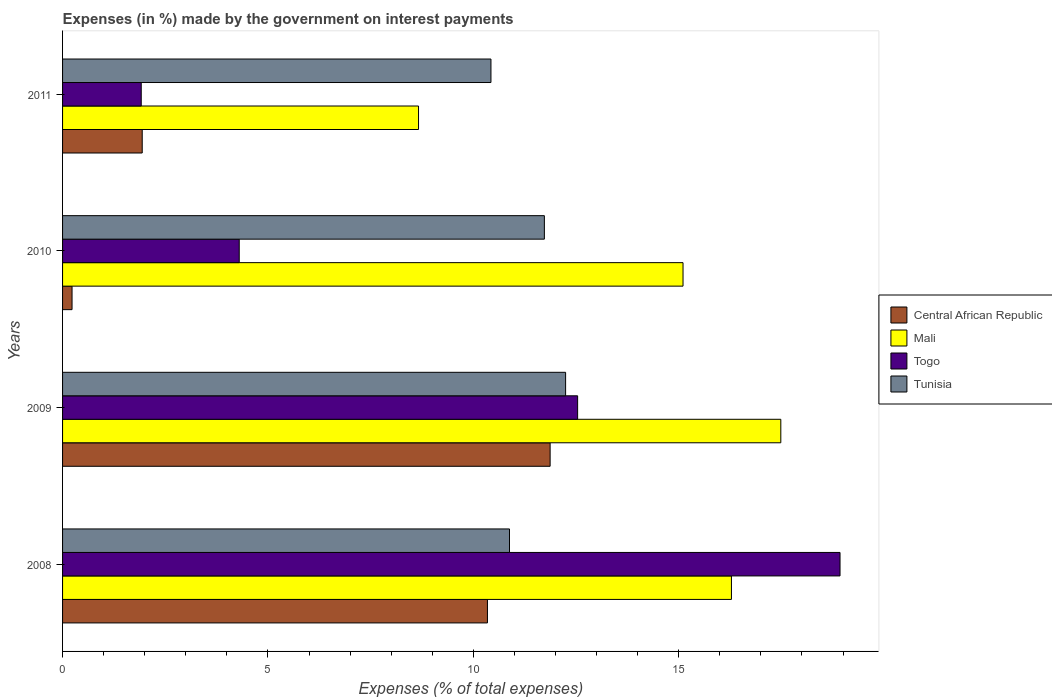Are the number of bars per tick equal to the number of legend labels?
Provide a short and direct response. Yes. How many bars are there on the 4th tick from the top?
Offer a terse response. 4. What is the label of the 3rd group of bars from the top?
Your answer should be very brief. 2009. In how many cases, is the number of bars for a given year not equal to the number of legend labels?
Give a very brief answer. 0. What is the percentage of expenses made by the government on interest payments in Tunisia in 2009?
Offer a terse response. 12.25. Across all years, what is the maximum percentage of expenses made by the government on interest payments in Mali?
Your response must be concise. 17.49. Across all years, what is the minimum percentage of expenses made by the government on interest payments in Mali?
Provide a succinct answer. 8.67. In which year was the percentage of expenses made by the government on interest payments in Mali maximum?
Your answer should be compact. 2009. In which year was the percentage of expenses made by the government on interest payments in Togo minimum?
Your answer should be compact. 2011. What is the total percentage of expenses made by the government on interest payments in Central African Republic in the graph?
Your answer should be very brief. 24.38. What is the difference between the percentage of expenses made by the government on interest payments in Tunisia in 2010 and that in 2011?
Offer a very short reply. 1.3. What is the difference between the percentage of expenses made by the government on interest payments in Tunisia in 2010 and the percentage of expenses made by the government on interest payments in Central African Republic in 2008?
Offer a terse response. 1.39. What is the average percentage of expenses made by the government on interest payments in Mali per year?
Offer a terse response. 14.39. In the year 2009, what is the difference between the percentage of expenses made by the government on interest payments in Tunisia and percentage of expenses made by the government on interest payments in Mali?
Make the answer very short. -5.24. What is the ratio of the percentage of expenses made by the government on interest payments in Central African Republic in 2008 to that in 2010?
Give a very brief answer. 44.79. Is the percentage of expenses made by the government on interest payments in Tunisia in 2010 less than that in 2011?
Offer a terse response. No. What is the difference between the highest and the second highest percentage of expenses made by the government on interest payments in Togo?
Your answer should be very brief. 6.39. What is the difference between the highest and the lowest percentage of expenses made by the government on interest payments in Tunisia?
Provide a succinct answer. 1.82. In how many years, is the percentage of expenses made by the government on interest payments in Tunisia greater than the average percentage of expenses made by the government on interest payments in Tunisia taken over all years?
Keep it short and to the point. 2. Is the sum of the percentage of expenses made by the government on interest payments in Tunisia in 2008 and 2010 greater than the maximum percentage of expenses made by the government on interest payments in Central African Republic across all years?
Ensure brevity in your answer.  Yes. What does the 2nd bar from the top in 2008 represents?
Your answer should be very brief. Togo. What does the 3rd bar from the bottom in 2011 represents?
Ensure brevity in your answer.  Togo. Is it the case that in every year, the sum of the percentage of expenses made by the government on interest payments in Togo and percentage of expenses made by the government on interest payments in Tunisia is greater than the percentage of expenses made by the government on interest payments in Central African Republic?
Your answer should be very brief. Yes. How many bars are there?
Make the answer very short. 16. How many years are there in the graph?
Your response must be concise. 4. What is the difference between two consecutive major ticks on the X-axis?
Offer a very short reply. 5. Are the values on the major ticks of X-axis written in scientific E-notation?
Your answer should be compact. No. Does the graph contain any zero values?
Give a very brief answer. No. Where does the legend appear in the graph?
Provide a succinct answer. Center right. How are the legend labels stacked?
Provide a short and direct response. Vertical. What is the title of the graph?
Offer a terse response. Expenses (in %) made by the government on interest payments. Does "Latin America(all income levels)" appear as one of the legend labels in the graph?
Your answer should be compact. No. What is the label or title of the X-axis?
Your answer should be compact. Expenses (% of total expenses). What is the label or title of the Y-axis?
Offer a very short reply. Years. What is the Expenses (% of total expenses) of Central African Republic in 2008?
Make the answer very short. 10.34. What is the Expenses (% of total expenses) of Mali in 2008?
Ensure brevity in your answer.  16.28. What is the Expenses (% of total expenses) of Togo in 2008?
Your response must be concise. 18.93. What is the Expenses (% of total expenses) of Tunisia in 2008?
Provide a succinct answer. 10.88. What is the Expenses (% of total expenses) of Central African Republic in 2009?
Ensure brevity in your answer.  11.87. What is the Expenses (% of total expenses) of Mali in 2009?
Offer a very short reply. 17.49. What is the Expenses (% of total expenses) in Togo in 2009?
Provide a short and direct response. 12.54. What is the Expenses (% of total expenses) of Tunisia in 2009?
Provide a short and direct response. 12.25. What is the Expenses (% of total expenses) of Central African Republic in 2010?
Make the answer very short. 0.23. What is the Expenses (% of total expenses) in Mali in 2010?
Provide a succinct answer. 15.11. What is the Expenses (% of total expenses) of Togo in 2010?
Your answer should be very brief. 4.3. What is the Expenses (% of total expenses) in Tunisia in 2010?
Provide a succinct answer. 11.73. What is the Expenses (% of total expenses) of Central African Republic in 2011?
Provide a succinct answer. 1.94. What is the Expenses (% of total expenses) in Mali in 2011?
Your answer should be compact. 8.67. What is the Expenses (% of total expenses) of Togo in 2011?
Provide a short and direct response. 1.92. What is the Expenses (% of total expenses) in Tunisia in 2011?
Provide a short and direct response. 10.43. Across all years, what is the maximum Expenses (% of total expenses) of Central African Republic?
Your answer should be compact. 11.87. Across all years, what is the maximum Expenses (% of total expenses) of Mali?
Ensure brevity in your answer.  17.49. Across all years, what is the maximum Expenses (% of total expenses) in Togo?
Your response must be concise. 18.93. Across all years, what is the maximum Expenses (% of total expenses) of Tunisia?
Offer a terse response. 12.25. Across all years, what is the minimum Expenses (% of total expenses) in Central African Republic?
Offer a terse response. 0.23. Across all years, what is the minimum Expenses (% of total expenses) of Mali?
Give a very brief answer. 8.67. Across all years, what is the minimum Expenses (% of total expenses) of Togo?
Offer a very short reply. 1.92. Across all years, what is the minimum Expenses (% of total expenses) in Tunisia?
Offer a very short reply. 10.43. What is the total Expenses (% of total expenses) of Central African Republic in the graph?
Make the answer very short. 24.38. What is the total Expenses (% of total expenses) of Mali in the graph?
Give a very brief answer. 57.54. What is the total Expenses (% of total expenses) of Togo in the graph?
Keep it short and to the point. 37.68. What is the total Expenses (% of total expenses) in Tunisia in the graph?
Ensure brevity in your answer.  45.29. What is the difference between the Expenses (% of total expenses) of Central African Republic in 2008 and that in 2009?
Your answer should be compact. -1.53. What is the difference between the Expenses (% of total expenses) of Mali in 2008 and that in 2009?
Your answer should be compact. -1.2. What is the difference between the Expenses (% of total expenses) in Togo in 2008 and that in 2009?
Offer a very short reply. 6.39. What is the difference between the Expenses (% of total expenses) of Tunisia in 2008 and that in 2009?
Ensure brevity in your answer.  -1.37. What is the difference between the Expenses (% of total expenses) of Central African Republic in 2008 and that in 2010?
Keep it short and to the point. 10.11. What is the difference between the Expenses (% of total expenses) in Mali in 2008 and that in 2010?
Your answer should be compact. 1.18. What is the difference between the Expenses (% of total expenses) in Togo in 2008 and that in 2010?
Offer a very short reply. 14.63. What is the difference between the Expenses (% of total expenses) in Tunisia in 2008 and that in 2010?
Offer a terse response. -0.85. What is the difference between the Expenses (% of total expenses) in Central African Republic in 2008 and that in 2011?
Offer a very short reply. 8.4. What is the difference between the Expenses (% of total expenses) of Mali in 2008 and that in 2011?
Your answer should be very brief. 7.62. What is the difference between the Expenses (% of total expenses) in Togo in 2008 and that in 2011?
Offer a terse response. 17.01. What is the difference between the Expenses (% of total expenses) in Tunisia in 2008 and that in 2011?
Your answer should be very brief. 0.45. What is the difference between the Expenses (% of total expenses) of Central African Republic in 2009 and that in 2010?
Your answer should be compact. 11.64. What is the difference between the Expenses (% of total expenses) of Mali in 2009 and that in 2010?
Provide a short and direct response. 2.38. What is the difference between the Expenses (% of total expenses) of Togo in 2009 and that in 2010?
Offer a terse response. 8.24. What is the difference between the Expenses (% of total expenses) of Tunisia in 2009 and that in 2010?
Ensure brevity in your answer.  0.52. What is the difference between the Expenses (% of total expenses) of Central African Republic in 2009 and that in 2011?
Provide a short and direct response. 9.93. What is the difference between the Expenses (% of total expenses) of Mali in 2009 and that in 2011?
Provide a short and direct response. 8.82. What is the difference between the Expenses (% of total expenses) of Togo in 2009 and that in 2011?
Make the answer very short. 10.62. What is the difference between the Expenses (% of total expenses) in Tunisia in 2009 and that in 2011?
Provide a succinct answer. 1.82. What is the difference between the Expenses (% of total expenses) of Central African Republic in 2010 and that in 2011?
Provide a succinct answer. -1.71. What is the difference between the Expenses (% of total expenses) of Mali in 2010 and that in 2011?
Your answer should be very brief. 6.44. What is the difference between the Expenses (% of total expenses) of Togo in 2010 and that in 2011?
Offer a terse response. 2.39. What is the difference between the Expenses (% of total expenses) in Tunisia in 2010 and that in 2011?
Offer a very short reply. 1.3. What is the difference between the Expenses (% of total expenses) in Central African Republic in 2008 and the Expenses (% of total expenses) in Mali in 2009?
Your answer should be very brief. -7.14. What is the difference between the Expenses (% of total expenses) in Central African Republic in 2008 and the Expenses (% of total expenses) in Togo in 2009?
Your answer should be compact. -2.2. What is the difference between the Expenses (% of total expenses) of Central African Republic in 2008 and the Expenses (% of total expenses) of Tunisia in 2009?
Ensure brevity in your answer.  -1.9. What is the difference between the Expenses (% of total expenses) of Mali in 2008 and the Expenses (% of total expenses) of Togo in 2009?
Make the answer very short. 3.74. What is the difference between the Expenses (% of total expenses) in Mali in 2008 and the Expenses (% of total expenses) in Tunisia in 2009?
Your answer should be compact. 4.04. What is the difference between the Expenses (% of total expenses) of Togo in 2008 and the Expenses (% of total expenses) of Tunisia in 2009?
Ensure brevity in your answer.  6.68. What is the difference between the Expenses (% of total expenses) of Central African Republic in 2008 and the Expenses (% of total expenses) of Mali in 2010?
Keep it short and to the point. -4.76. What is the difference between the Expenses (% of total expenses) in Central African Republic in 2008 and the Expenses (% of total expenses) in Togo in 2010?
Provide a succinct answer. 6.04. What is the difference between the Expenses (% of total expenses) in Central African Republic in 2008 and the Expenses (% of total expenses) in Tunisia in 2010?
Your answer should be compact. -1.39. What is the difference between the Expenses (% of total expenses) of Mali in 2008 and the Expenses (% of total expenses) of Togo in 2010?
Offer a very short reply. 11.98. What is the difference between the Expenses (% of total expenses) in Mali in 2008 and the Expenses (% of total expenses) in Tunisia in 2010?
Your answer should be compact. 4.55. What is the difference between the Expenses (% of total expenses) of Togo in 2008 and the Expenses (% of total expenses) of Tunisia in 2010?
Offer a terse response. 7.2. What is the difference between the Expenses (% of total expenses) of Central African Republic in 2008 and the Expenses (% of total expenses) of Mali in 2011?
Your answer should be compact. 1.68. What is the difference between the Expenses (% of total expenses) in Central African Republic in 2008 and the Expenses (% of total expenses) in Togo in 2011?
Your response must be concise. 8.43. What is the difference between the Expenses (% of total expenses) of Central African Republic in 2008 and the Expenses (% of total expenses) of Tunisia in 2011?
Your answer should be compact. -0.09. What is the difference between the Expenses (% of total expenses) in Mali in 2008 and the Expenses (% of total expenses) in Togo in 2011?
Your answer should be compact. 14.37. What is the difference between the Expenses (% of total expenses) in Mali in 2008 and the Expenses (% of total expenses) in Tunisia in 2011?
Offer a very short reply. 5.85. What is the difference between the Expenses (% of total expenses) in Togo in 2008 and the Expenses (% of total expenses) in Tunisia in 2011?
Keep it short and to the point. 8.5. What is the difference between the Expenses (% of total expenses) of Central African Republic in 2009 and the Expenses (% of total expenses) of Mali in 2010?
Provide a succinct answer. -3.24. What is the difference between the Expenses (% of total expenses) of Central African Republic in 2009 and the Expenses (% of total expenses) of Togo in 2010?
Ensure brevity in your answer.  7.57. What is the difference between the Expenses (% of total expenses) of Central African Republic in 2009 and the Expenses (% of total expenses) of Tunisia in 2010?
Provide a succinct answer. 0.14. What is the difference between the Expenses (% of total expenses) in Mali in 2009 and the Expenses (% of total expenses) in Togo in 2010?
Provide a short and direct response. 13.19. What is the difference between the Expenses (% of total expenses) in Mali in 2009 and the Expenses (% of total expenses) in Tunisia in 2010?
Provide a short and direct response. 5.76. What is the difference between the Expenses (% of total expenses) of Togo in 2009 and the Expenses (% of total expenses) of Tunisia in 2010?
Your response must be concise. 0.81. What is the difference between the Expenses (% of total expenses) of Central African Republic in 2009 and the Expenses (% of total expenses) of Mali in 2011?
Make the answer very short. 3.2. What is the difference between the Expenses (% of total expenses) in Central African Republic in 2009 and the Expenses (% of total expenses) in Togo in 2011?
Your response must be concise. 9.95. What is the difference between the Expenses (% of total expenses) in Central African Republic in 2009 and the Expenses (% of total expenses) in Tunisia in 2011?
Provide a succinct answer. 1.44. What is the difference between the Expenses (% of total expenses) of Mali in 2009 and the Expenses (% of total expenses) of Togo in 2011?
Offer a terse response. 15.57. What is the difference between the Expenses (% of total expenses) in Mali in 2009 and the Expenses (% of total expenses) in Tunisia in 2011?
Ensure brevity in your answer.  7.06. What is the difference between the Expenses (% of total expenses) of Togo in 2009 and the Expenses (% of total expenses) of Tunisia in 2011?
Your response must be concise. 2.11. What is the difference between the Expenses (% of total expenses) in Central African Republic in 2010 and the Expenses (% of total expenses) in Mali in 2011?
Your response must be concise. -8.44. What is the difference between the Expenses (% of total expenses) of Central African Republic in 2010 and the Expenses (% of total expenses) of Togo in 2011?
Provide a short and direct response. -1.68. What is the difference between the Expenses (% of total expenses) in Central African Republic in 2010 and the Expenses (% of total expenses) in Tunisia in 2011?
Offer a terse response. -10.2. What is the difference between the Expenses (% of total expenses) of Mali in 2010 and the Expenses (% of total expenses) of Togo in 2011?
Offer a very short reply. 13.19. What is the difference between the Expenses (% of total expenses) in Mali in 2010 and the Expenses (% of total expenses) in Tunisia in 2011?
Make the answer very short. 4.68. What is the difference between the Expenses (% of total expenses) in Togo in 2010 and the Expenses (% of total expenses) in Tunisia in 2011?
Your answer should be very brief. -6.13. What is the average Expenses (% of total expenses) in Central African Republic per year?
Offer a very short reply. 6.1. What is the average Expenses (% of total expenses) in Mali per year?
Provide a succinct answer. 14.39. What is the average Expenses (% of total expenses) of Togo per year?
Offer a terse response. 9.42. What is the average Expenses (% of total expenses) in Tunisia per year?
Offer a terse response. 11.32. In the year 2008, what is the difference between the Expenses (% of total expenses) in Central African Republic and Expenses (% of total expenses) in Mali?
Make the answer very short. -5.94. In the year 2008, what is the difference between the Expenses (% of total expenses) of Central African Republic and Expenses (% of total expenses) of Togo?
Provide a succinct answer. -8.58. In the year 2008, what is the difference between the Expenses (% of total expenses) of Central African Republic and Expenses (% of total expenses) of Tunisia?
Offer a very short reply. -0.54. In the year 2008, what is the difference between the Expenses (% of total expenses) of Mali and Expenses (% of total expenses) of Togo?
Your answer should be very brief. -2.64. In the year 2008, what is the difference between the Expenses (% of total expenses) of Mali and Expenses (% of total expenses) of Tunisia?
Your response must be concise. 5.4. In the year 2008, what is the difference between the Expenses (% of total expenses) in Togo and Expenses (% of total expenses) in Tunisia?
Make the answer very short. 8.05. In the year 2009, what is the difference between the Expenses (% of total expenses) of Central African Republic and Expenses (% of total expenses) of Mali?
Offer a very short reply. -5.62. In the year 2009, what is the difference between the Expenses (% of total expenses) of Central African Republic and Expenses (% of total expenses) of Togo?
Offer a terse response. -0.67. In the year 2009, what is the difference between the Expenses (% of total expenses) in Central African Republic and Expenses (% of total expenses) in Tunisia?
Your answer should be compact. -0.38. In the year 2009, what is the difference between the Expenses (% of total expenses) in Mali and Expenses (% of total expenses) in Togo?
Provide a short and direct response. 4.95. In the year 2009, what is the difference between the Expenses (% of total expenses) of Mali and Expenses (% of total expenses) of Tunisia?
Offer a very short reply. 5.24. In the year 2009, what is the difference between the Expenses (% of total expenses) of Togo and Expenses (% of total expenses) of Tunisia?
Offer a very short reply. 0.29. In the year 2010, what is the difference between the Expenses (% of total expenses) in Central African Republic and Expenses (% of total expenses) in Mali?
Provide a short and direct response. -14.87. In the year 2010, what is the difference between the Expenses (% of total expenses) of Central African Republic and Expenses (% of total expenses) of Togo?
Your answer should be compact. -4.07. In the year 2010, what is the difference between the Expenses (% of total expenses) of Central African Republic and Expenses (% of total expenses) of Tunisia?
Offer a terse response. -11.5. In the year 2010, what is the difference between the Expenses (% of total expenses) of Mali and Expenses (% of total expenses) of Togo?
Ensure brevity in your answer.  10.8. In the year 2010, what is the difference between the Expenses (% of total expenses) of Mali and Expenses (% of total expenses) of Tunisia?
Provide a succinct answer. 3.38. In the year 2010, what is the difference between the Expenses (% of total expenses) of Togo and Expenses (% of total expenses) of Tunisia?
Your response must be concise. -7.43. In the year 2011, what is the difference between the Expenses (% of total expenses) of Central African Republic and Expenses (% of total expenses) of Mali?
Offer a very short reply. -6.73. In the year 2011, what is the difference between the Expenses (% of total expenses) of Central African Republic and Expenses (% of total expenses) of Togo?
Provide a succinct answer. 0.02. In the year 2011, what is the difference between the Expenses (% of total expenses) in Central African Republic and Expenses (% of total expenses) in Tunisia?
Your answer should be compact. -8.49. In the year 2011, what is the difference between the Expenses (% of total expenses) in Mali and Expenses (% of total expenses) in Togo?
Provide a short and direct response. 6.75. In the year 2011, what is the difference between the Expenses (% of total expenses) of Mali and Expenses (% of total expenses) of Tunisia?
Make the answer very short. -1.76. In the year 2011, what is the difference between the Expenses (% of total expenses) in Togo and Expenses (% of total expenses) in Tunisia?
Keep it short and to the point. -8.51. What is the ratio of the Expenses (% of total expenses) of Central African Republic in 2008 to that in 2009?
Your response must be concise. 0.87. What is the ratio of the Expenses (% of total expenses) in Mali in 2008 to that in 2009?
Offer a terse response. 0.93. What is the ratio of the Expenses (% of total expenses) of Togo in 2008 to that in 2009?
Offer a very short reply. 1.51. What is the ratio of the Expenses (% of total expenses) of Tunisia in 2008 to that in 2009?
Make the answer very short. 0.89. What is the ratio of the Expenses (% of total expenses) in Central African Republic in 2008 to that in 2010?
Provide a succinct answer. 44.79. What is the ratio of the Expenses (% of total expenses) of Mali in 2008 to that in 2010?
Your response must be concise. 1.08. What is the ratio of the Expenses (% of total expenses) of Togo in 2008 to that in 2010?
Provide a succinct answer. 4.4. What is the ratio of the Expenses (% of total expenses) in Tunisia in 2008 to that in 2010?
Make the answer very short. 0.93. What is the ratio of the Expenses (% of total expenses) in Central African Republic in 2008 to that in 2011?
Provide a short and direct response. 5.33. What is the ratio of the Expenses (% of total expenses) of Mali in 2008 to that in 2011?
Offer a terse response. 1.88. What is the ratio of the Expenses (% of total expenses) in Togo in 2008 to that in 2011?
Your answer should be very brief. 9.88. What is the ratio of the Expenses (% of total expenses) in Tunisia in 2008 to that in 2011?
Provide a succinct answer. 1.04. What is the ratio of the Expenses (% of total expenses) in Central African Republic in 2009 to that in 2010?
Offer a terse response. 51.4. What is the ratio of the Expenses (% of total expenses) in Mali in 2009 to that in 2010?
Give a very brief answer. 1.16. What is the ratio of the Expenses (% of total expenses) of Togo in 2009 to that in 2010?
Your answer should be compact. 2.92. What is the ratio of the Expenses (% of total expenses) in Tunisia in 2009 to that in 2010?
Your answer should be compact. 1.04. What is the ratio of the Expenses (% of total expenses) in Central African Republic in 2009 to that in 2011?
Your answer should be compact. 6.12. What is the ratio of the Expenses (% of total expenses) in Mali in 2009 to that in 2011?
Provide a short and direct response. 2.02. What is the ratio of the Expenses (% of total expenses) in Togo in 2009 to that in 2011?
Make the answer very short. 6.55. What is the ratio of the Expenses (% of total expenses) in Tunisia in 2009 to that in 2011?
Give a very brief answer. 1.17. What is the ratio of the Expenses (% of total expenses) in Central African Republic in 2010 to that in 2011?
Give a very brief answer. 0.12. What is the ratio of the Expenses (% of total expenses) of Mali in 2010 to that in 2011?
Provide a succinct answer. 1.74. What is the ratio of the Expenses (% of total expenses) in Togo in 2010 to that in 2011?
Offer a terse response. 2.25. What is the ratio of the Expenses (% of total expenses) in Tunisia in 2010 to that in 2011?
Offer a very short reply. 1.12. What is the difference between the highest and the second highest Expenses (% of total expenses) in Central African Republic?
Your answer should be compact. 1.53. What is the difference between the highest and the second highest Expenses (% of total expenses) of Mali?
Offer a terse response. 1.2. What is the difference between the highest and the second highest Expenses (% of total expenses) of Togo?
Make the answer very short. 6.39. What is the difference between the highest and the second highest Expenses (% of total expenses) of Tunisia?
Offer a very short reply. 0.52. What is the difference between the highest and the lowest Expenses (% of total expenses) of Central African Republic?
Your answer should be compact. 11.64. What is the difference between the highest and the lowest Expenses (% of total expenses) in Mali?
Ensure brevity in your answer.  8.82. What is the difference between the highest and the lowest Expenses (% of total expenses) in Togo?
Make the answer very short. 17.01. What is the difference between the highest and the lowest Expenses (% of total expenses) in Tunisia?
Your response must be concise. 1.82. 